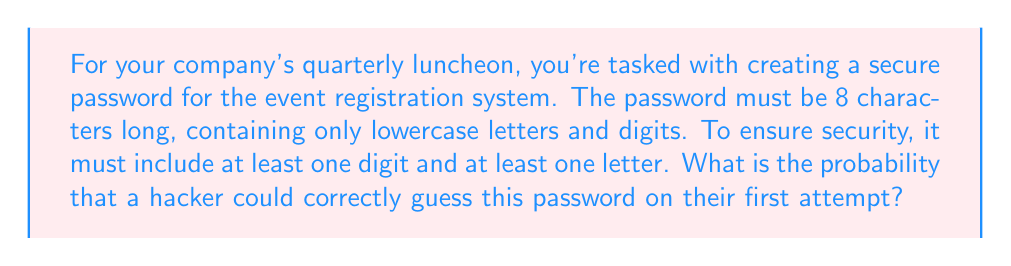Can you solve this math problem? Let's approach this step-by-step:

1) First, we need to calculate the total number of possible characters:
   - 26 lowercase letters
   - 10 digits
   Total: 26 + 10 = 36 characters

2) Now, let's consider the possible combinations:
   - We need 8 characters in total
   - We need at least one digit and one letter

3) To calculate this, it's easier to subtract the invalid combinations from the total:
   
   Total combinations: $36^8$
   
   Invalid combinations:
   - All letters: $26^8$
   - All digits: $10^8$

4) Therefore, valid combinations = $36^8 - 26^8 - 10^8$

5) The probability is the number of favorable outcomes divided by the total number of possible outcomes. In this case, it's 1 (the correct password) divided by the number of valid combinations:

   $$P(\text{correct guess}) = \frac{1}{36^8 - 26^8 - 10^8}$$

6) Calculating this:
   
   $$P(\text{correct guess}) = \frac{1}{2,821,109,907,456 - 208,827,064,576 - 100,000,000}$$
   $$= \frac{1}{2,612,182,842,880}$$
   $$\approx 3.828 \times 10^{-13}$$
Answer: $\frac{1}{2,612,182,842,880}$ or $\approx 3.828 \times 10^{-13}$ 